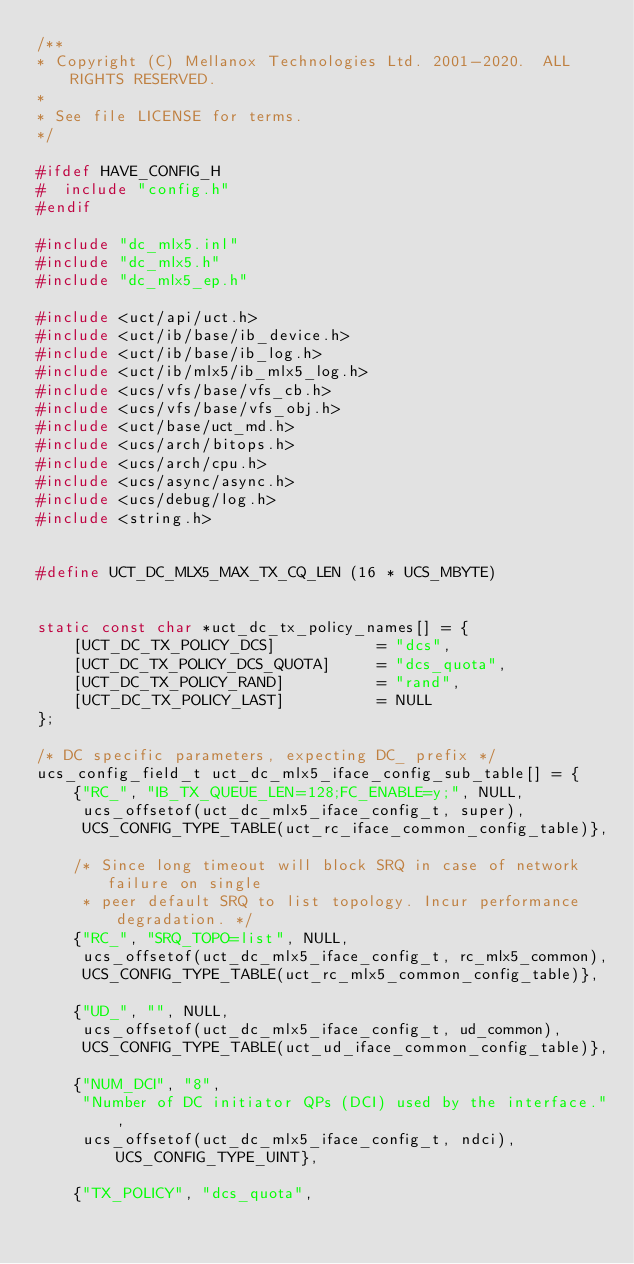Convert code to text. <code><loc_0><loc_0><loc_500><loc_500><_C_>/**
* Copyright (C) Mellanox Technologies Ltd. 2001-2020.  ALL RIGHTS RESERVED.
*
* See file LICENSE for terms.
*/

#ifdef HAVE_CONFIG_H
#  include "config.h"
#endif

#include "dc_mlx5.inl"
#include "dc_mlx5.h"
#include "dc_mlx5_ep.h"

#include <uct/api/uct.h>
#include <uct/ib/base/ib_device.h>
#include <uct/ib/base/ib_log.h>
#include <uct/ib/mlx5/ib_mlx5_log.h>
#include <ucs/vfs/base/vfs_cb.h>
#include <ucs/vfs/base/vfs_obj.h>
#include <uct/base/uct_md.h>
#include <ucs/arch/bitops.h>
#include <ucs/arch/cpu.h>
#include <ucs/async/async.h>
#include <ucs/debug/log.h>
#include <string.h>


#define UCT_DC_MLX5_MAX_TX_CQ_LEN (16 * UCS_MBYTE)


static const char *uct_dc_tx_policy_names[] = {
    [UCT_DC_TX_POLICY_DCS]           = "dcs",
    [UCT_DC_TX_POLICY_DCS_QUOTA]     = "dcs_quota",
    [UCT_DC_TX_POLICY_RAND]          = "rand",
    [UCT_DC_TX_POLICY_LAST]          = NULL
};

/* DC specific parameters, expecting DC_ prefix */
ucs_config_field_t uct_dc_mlx5_iface_config_sub_table[] = {
    {"RC_", "IB_TX_QUEUE_LEN=128;FC_ENABLE=y;", NULL,
     ucs_offsetof(uct_dc_mlx5_iface_config_t, super),
     UCS_CONFIG_TYPE_TABLE(uct_rc_iface_common_config_table)},

    /* Since long timeout will block SRQ in case of network failure on single
     * peer default SRQ to list topology. Incur performance degradation. */
    {"RC_", "SRQ_TOPO=list", NULL,
     ucs_offsetof(uct_dc_mlx5_iface_config_t, rc_mlx5_common),
     UCS_CONFIG_TYPE_TABLE(uct_rc_mlx5_common_config_table)},

    {"UD_", "", NULL,
     ucs_offsetof(uct_dc_mlx5_iface_config_t, ud_common),
     UCS_CONFIG_TYPE_TABLE(uct_ud_iface_common_config_table)},

    {"NUM_DCI", "8",
     "Number of DC initiator QPs (DCI) used by the interface.",
     ucs_offsetof(uct_dc_mlx5_iface_config_t, ndci), UCS_CONFIG_TYPE_UINT},

    {"TX_POLICY", "dcs_quota",</code> 